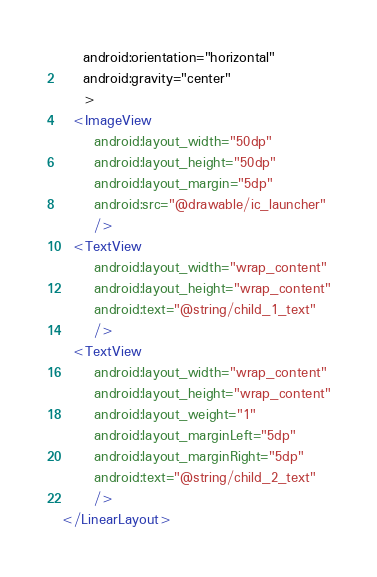Convert code to text. <code><loc_0><loc_0><loc_500><loc_500><_XML_>    android:orientation="horizontal"
    android:gravity="center"
    >
  <ImageView
      android:layout_width="50dp"
      android:layout_height="50dp"
      android:layout_margin="5dp"
      android:src="@drawable/ic_launcher"
      />
  <TextView
      android:layout_width="wrap_content"
      android:layout_height="wrap_content"
      android:text="@string/child_1_text"
      />
  <TextView
      android:layout_width="wrap_content"
      android:layout_height="wrap_content"
      android:layout_weight="1"
      android:layout_marginLeft="5dp"
      android:layout_marginRight="5dp"
      android:text="@string/child_2_text"
      />
</LinearLayout>
</code> 